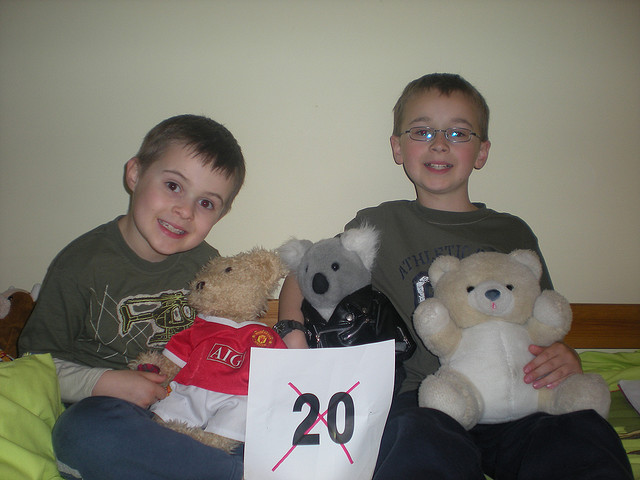Which bear seems to be the favorite based on its position? The traditional teddy bear being held by the child on the right might be a favorite, given its central position and the child's gentle embrace.  Can you tell if there's any special occasion? The number '20' prominently displayed in the image suggests a possible celebration or milestone event, perhaps a birthday or an anniversary of a special date. 